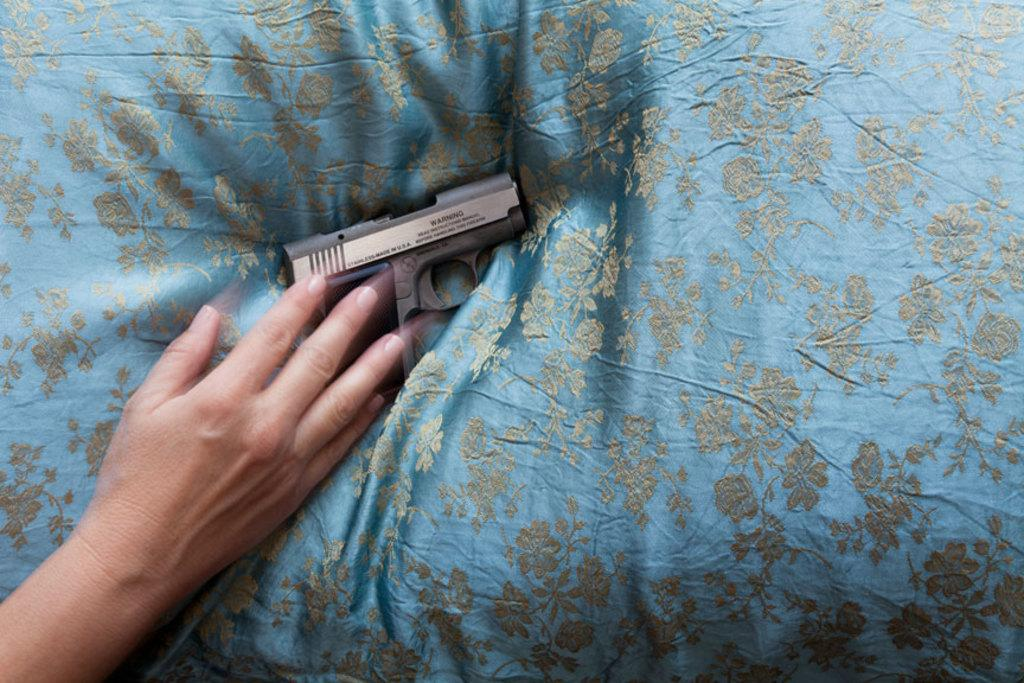What is present on the pillow in the image? There is a person's hand and a gun on the pillow. Can you describe the position of the hand on the pillow? The hand is on the pillow. What type of day is depicted in the image? There is no information about the day or time of day in the image. Can you see any planes in the image? There are no planes present in the image. 